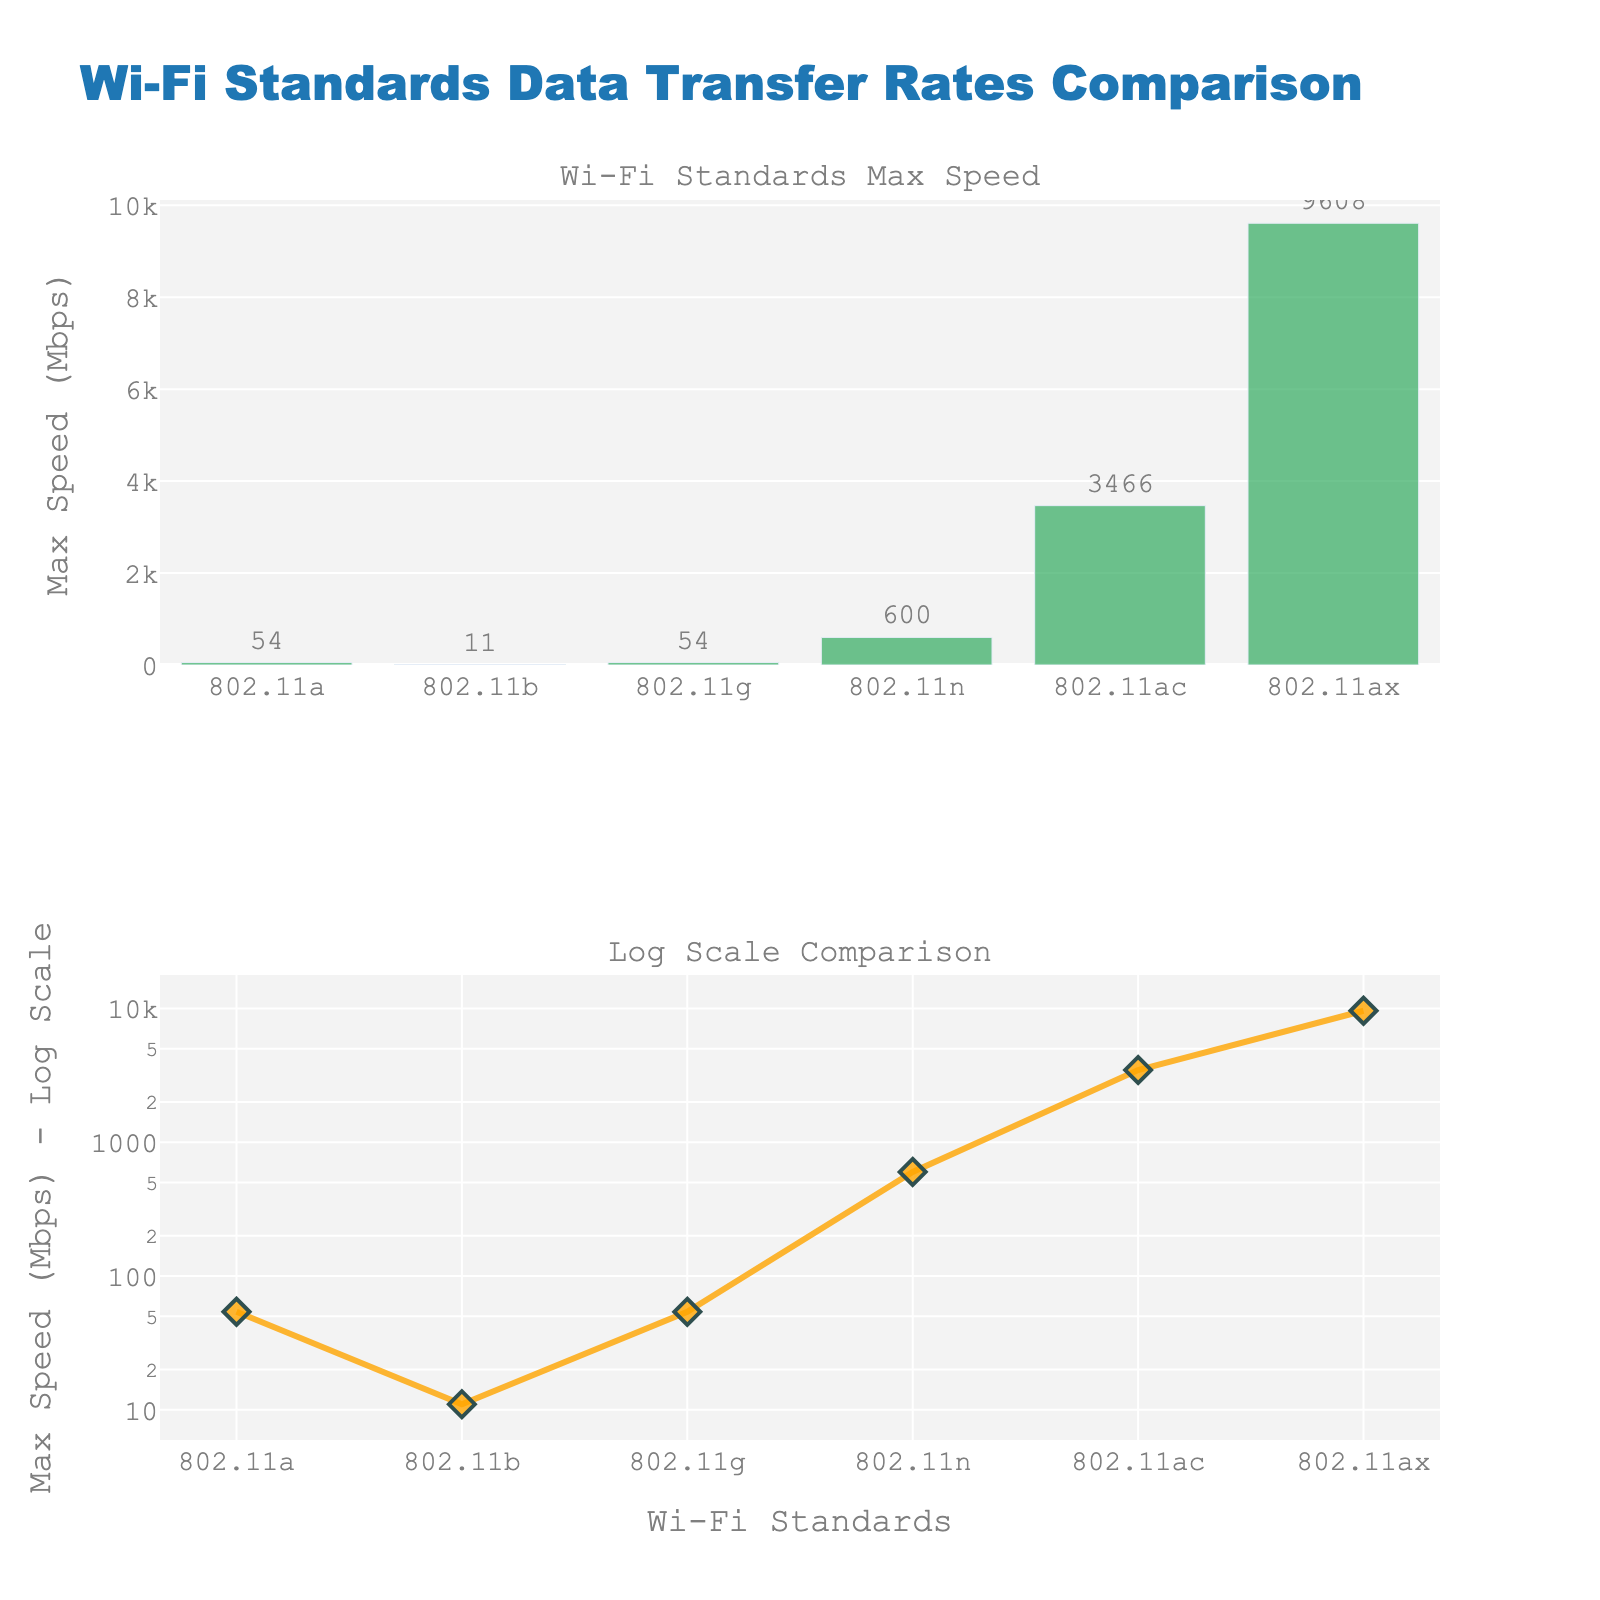What's the title of the figure? The title is located at the top center of the figure and it reads "Changes in Sleep Quality and Duration with Nutritional Therapy."
Answer: Changes in Sleep Quality and Duration with Nutritional Therapy How many weeks are displayed in the figure? The x-axis shows the weeks, starting from "Before Therapy" and ending at "After Therapy," including 8 weeks of data in between. In total, there are 10 data points (weeks).
Answer: 10 What's the range of values on the y-axis for Sleep Quality? The y-axis for Sleep Quality is updated to range from 0 to 10, which is specified by the visual adjustments in the layout of the figure.
Answer: 0 to 10 What was the Sleep Quality before starting the nutritional therapy? The first data point on the "Sleep Quality" subplot corresponding to "Before Therapy" shows a value of 4.
Answer: 4 How much did Sleep Duration increase from "Before Therapy" to "After Therapy"? Sleep Duration increased from 5.5 hours "Before Therapy" to 9 hours "After Therapy." The difference is calculated as 9 - 5.5.
Answer: 3.5 hours What's the average Sleep Duration during the therapy weeks (from week 1 to week 8)? Add the Sleep Duration from week 1 to week 8 and divide by 8: (6 + 6.5 + 7 + 7.5 + 8 + 8 + 8.5 + 8.5) / 8.
Answer: 7.5 hours During which week did Sleep Quality reach a value of 8? In the "Sleep Quality" subplot, week 6 is the first instance where the Sleep Quality reaches 8.
Answer: Week 6 What can be inferred about the trend in Sleep Quality over the duration of the therapy? By analyzing the "Sleep Quality" subplot, it is evident that there is a consistent upward trend, with values increasing from 4 to 9 over the duration shown.
Answer: It consistently increased Between which two consecutive weeks did Sleep Duration increase the most? The significant increase is observed between week 4 and week 5, where Sleep Duration rose from 7.5 hours to 8 hours, marking an increase of 0.5 hours.
Answer: Week 4 and Week 5 Compare Sleep Duration at week 1 and week 8. Which one is higher and by how much? At week 1, Sleep Duration is 6 hours, and at week 8, it is 8.5 hours. The difference is calculated as 8.5 - 6.
Answer: Week 8 is higher by 2.5 hours 